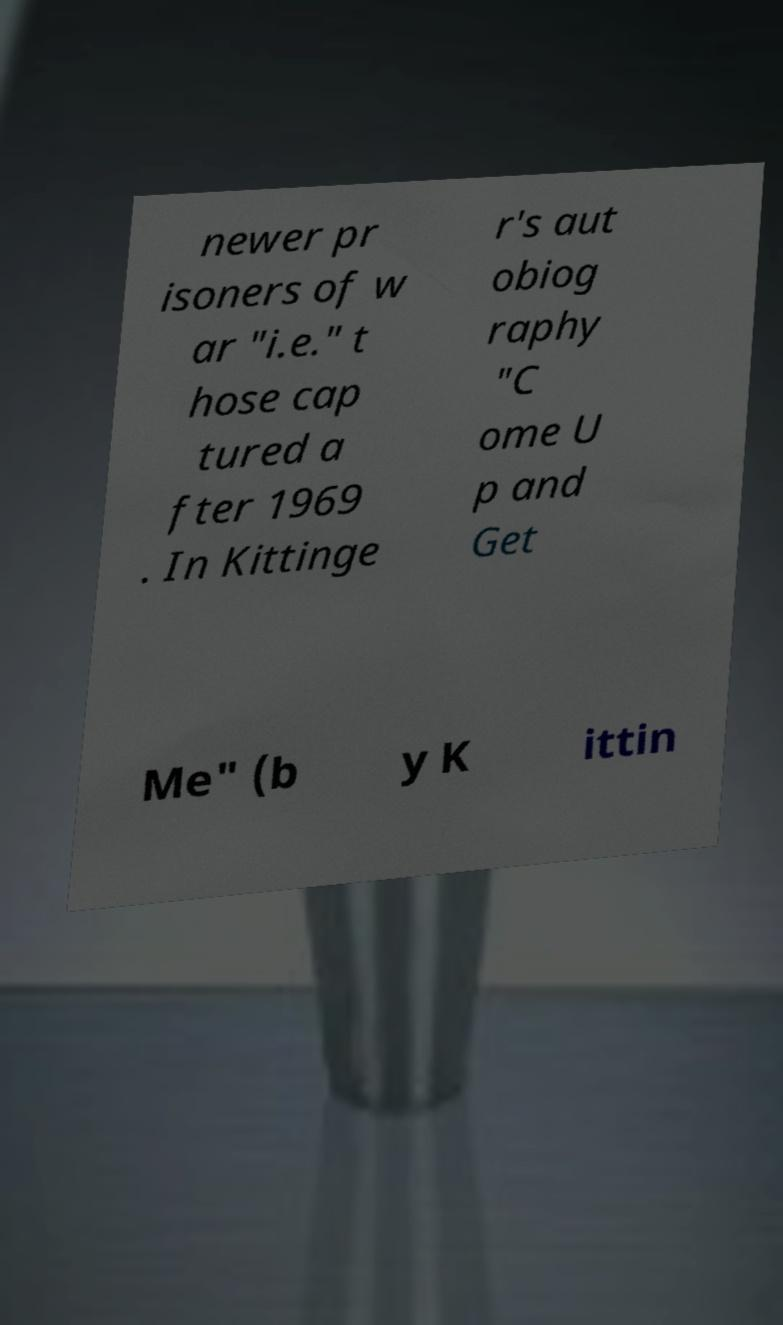I need the written content from this picture converted into text. Can you do that? newer pr isoners of w ar "i.e." t hose cap tured a fter 1969 . In Kittinge r's aut obiog raphy "C ome U p and Get Me" (b y K ittin 